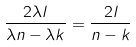<formula> <loc_0><loc_0><loc_500><loc_500>\frac { 2 \lambda l } { \lambda n - \lambda k } = \frac { 2 l } { n - k }</formula> 